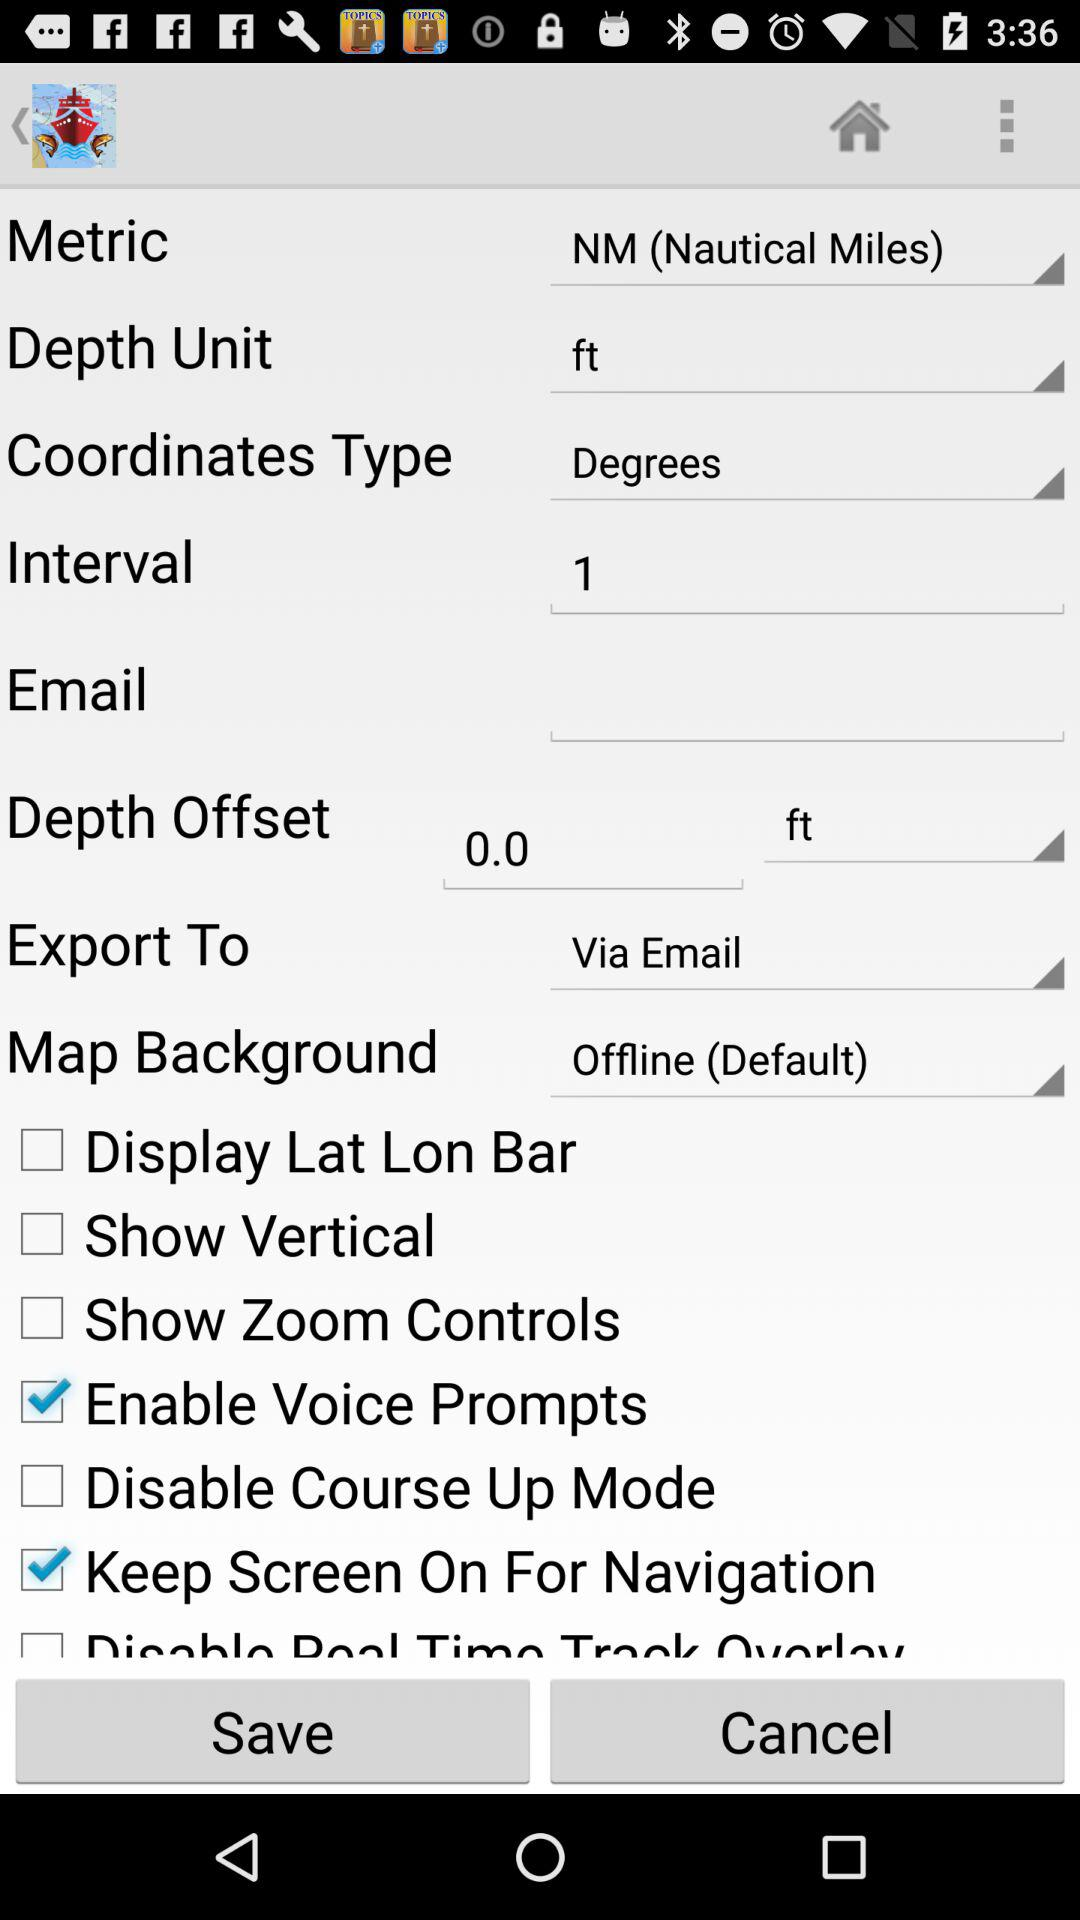Can the depth unit be in inches instead?
When the provided information is insufficient, respond with <no answer>. <no answer> 